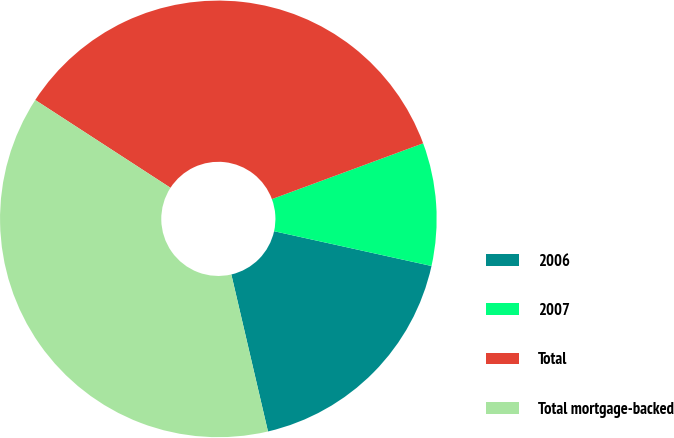Convert chart. <chart><loc_0><loc_0><loc_500><loc_500><pie_chart><fcel>2006<fcel>2007<fcel>Total<fcel>Total mortgage-backed<nl><fcel>17.89%<fcel>9.09%<fcel>35.21%<fcel>37.82%<nl></chart> 